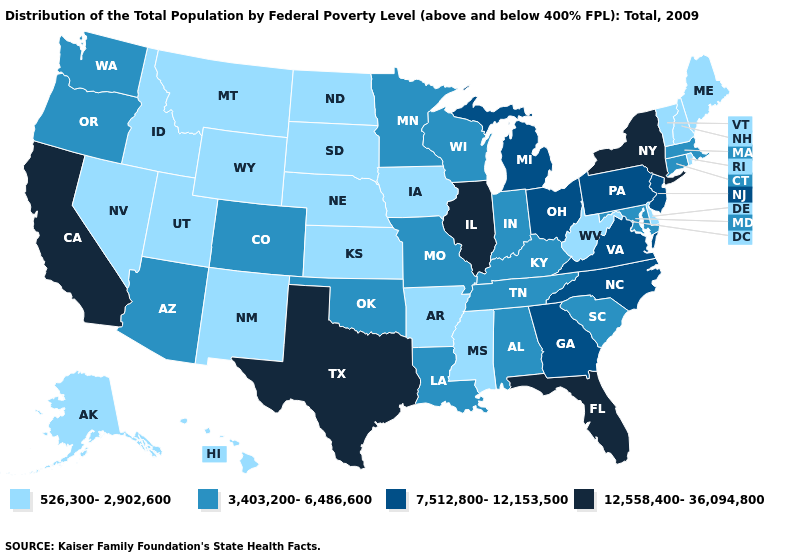Name the states that have a value in the range 7,512,800-12,153,500?
Be succinct. Georgia, Michigan, New Jersey, North Carolina, Ohio, Pennsylvania, Virginia. What is the value of Georgia?
Give a very brief answer. 7,512,800-12,153,500. What is the value of Pennsylvania?
Give a very brief answer. 7,512,800-12,153,500. Name the states that have a value in the range 7,512,800-12,153,500?
Give a very brief answer. Georgia, Michigan, New Jersey, North Carolina, Ohio, Pennsylvania, Virginia. Among the states that border New Hampshire , which have the lowest value?
Answer briefly. Maine, Vermont. What is the value of Missouri?
Give a very brief answer. 3,403,200-6,486,600. What is the lowest value in the USA?
Be succinct. 526,300-2,902,600. How many symbols are there in the legend?
Keep it brief. 4. What is the lowest value in the USA?
Write a very short answer. 526,300-2,902,600. What is the highest value in the USA?
Concise answer only. 12,558,400-36,094,800. What is the highest value in the Northeast ?
Short answer required. 12,558,400-36,094,800. What is the lowest value in the MidWest?
Write a very short answer. 526,300-2,902,600. Name the states that have a value in the range 526,300-2,902,600?
Answer briefly. Alaska, Arkansas, Delaware, Hawaii, Idaho, Iowa, Kansas, Maine, Mississippi, Montana, Nebraska, Nevada, New Hampshire, New Mexico, North Dakota, Rhode Island, South Dakota, Utah, Vermont, West Virginia, Wyoming. What is the lowest value in the Northeast?
Concise answer only. 526,300-2,902,600. What is the value of Kentucky?
Quick response, please. 3,403,200-6,486,600. 